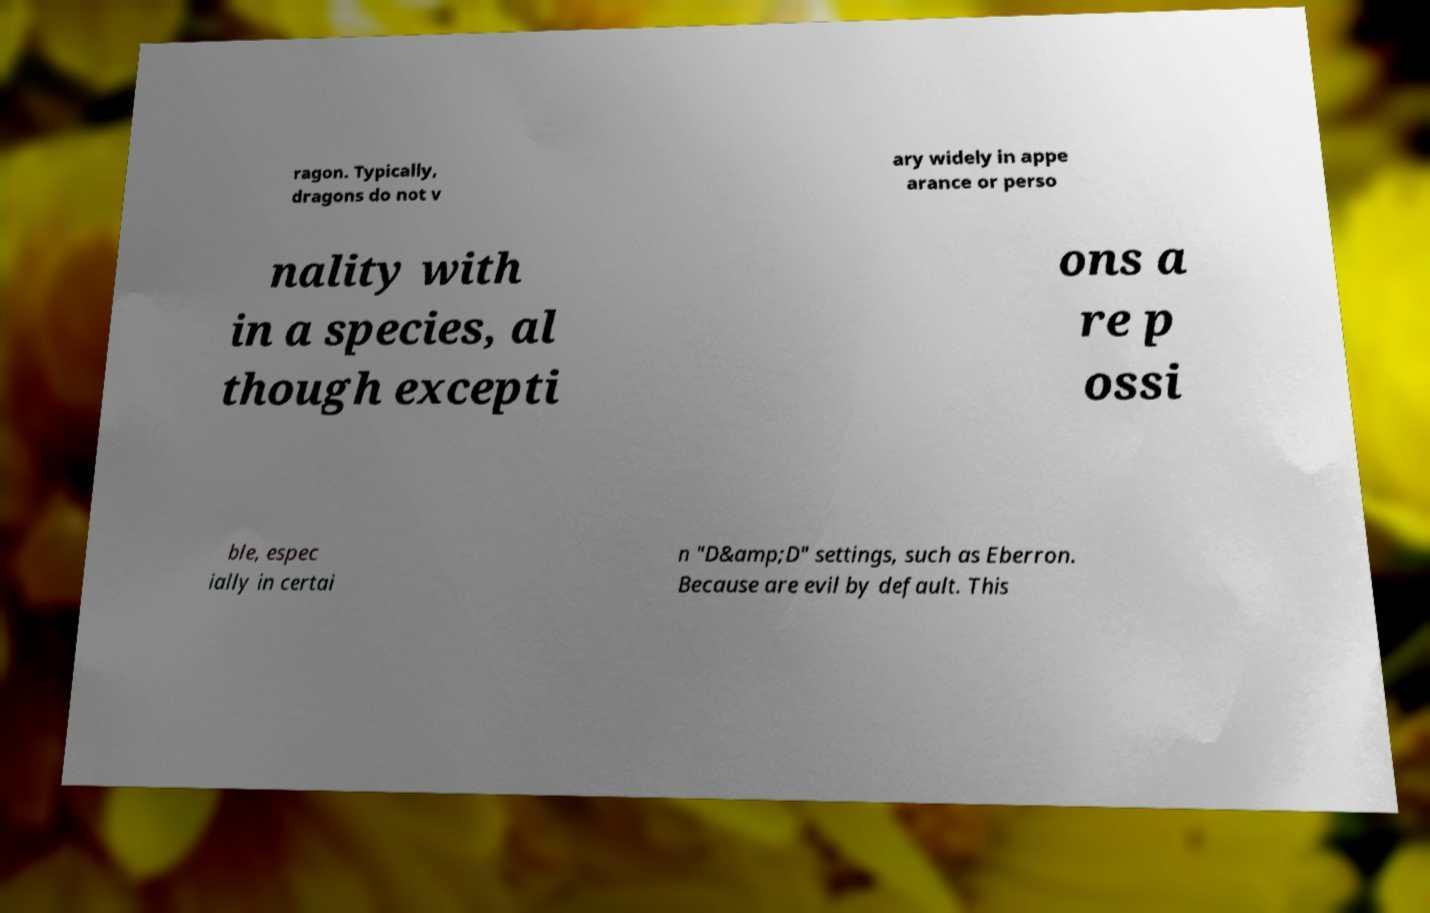Please read and relay the text visible in this image. What does it say? ragon. Typically, dragons do not v ary widely in appe arance or perso nality with in a species, al though excepti ons a re p ossi ble, espec ially in certai n "D&amp;D" settings, such as Eberron. Because are evil by default. This 